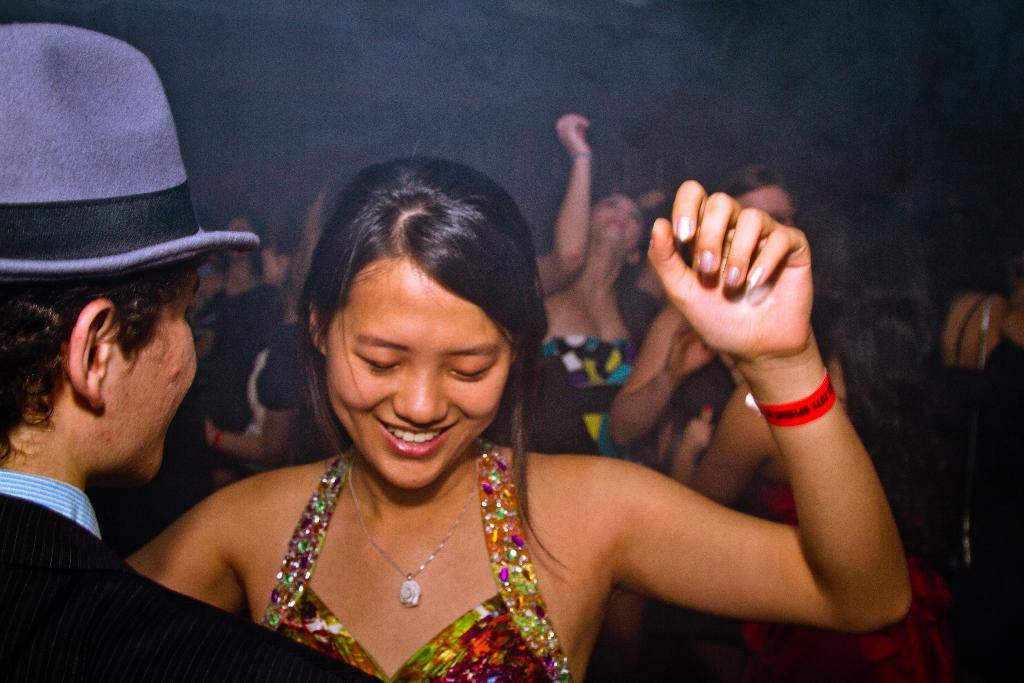What is the main subject in the foreground of the image? There is a man wearing a hat in the foreground of the image. Who is in front of the man in the foreground? There is a woman in front of the man in the foreground of the image. What can be seen in the background of the image? In the background, there are people visible. How would you describe the lighting in the background of the image? The background appears to be dark. Can you see the seashore in the background of the image? There is no seashore visible in the image; it features a man wearing a hat, a woman in front of him, and people in the background with dark lighting. 